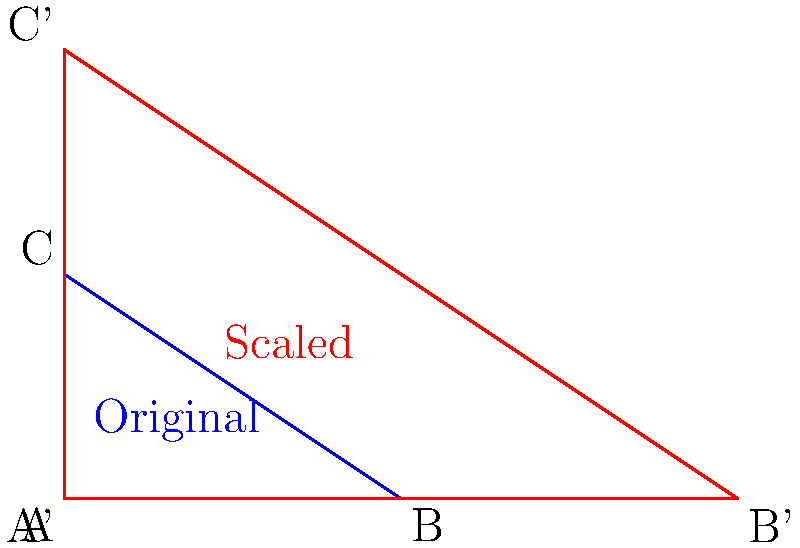In your analysis of mental health applications, you encounter a scenario where a triangular user interface element needs to be scaled. The original triangle ABC has vertices at (0,0), (3,0), and (0,2). If this triangle is uniformly scaled by a factor of 2, how does the area of the resulting triangle A'B'C' compare to the area of the original triangle ABC? Let's approach this step-by-step:

1) First, we need to calculate the area of the original triangle ABC.
   Area of a triangle = $\frac{1}{2} \times base \times height$
   Base = 3, Height = 2
   Area of ABC = $\frac{1}{2} \times 3 \times 2 = 3$ square units

2) Now, let's consider the scaled triangle A'B'C':
   - A' is at (0,0)
   - B' is at (6,0)
   - C' is at (0,4)

3) The scaling factor is 2, which means all linear dimensions are doubled.
   New base = 3 × 2 = 6
   New height = 2 × 2 = 4

4) Area of A'B'C' = $\frac{1}{2} \times 6 \times 4 = 12$ square units

5) To compare the areas, we can divide the new area by the original area:
   $\frac{\text{Area of A'B'C'}}{\text{Area of ABC}} = \frac{12}{3} = 4$

6) This result can also be derived from the scaling factor:
   When a 2D shape is scaled by a factor of k, its area is scaled by a factor of $k^2$.
   In this case, $k = 2$, so the area scale factor is $2^2 = 4$.

Therefore, the area of the scaled triangle A'B'C' is 4 times the area of the original triangle ABC.
Answer: 4 times larger 